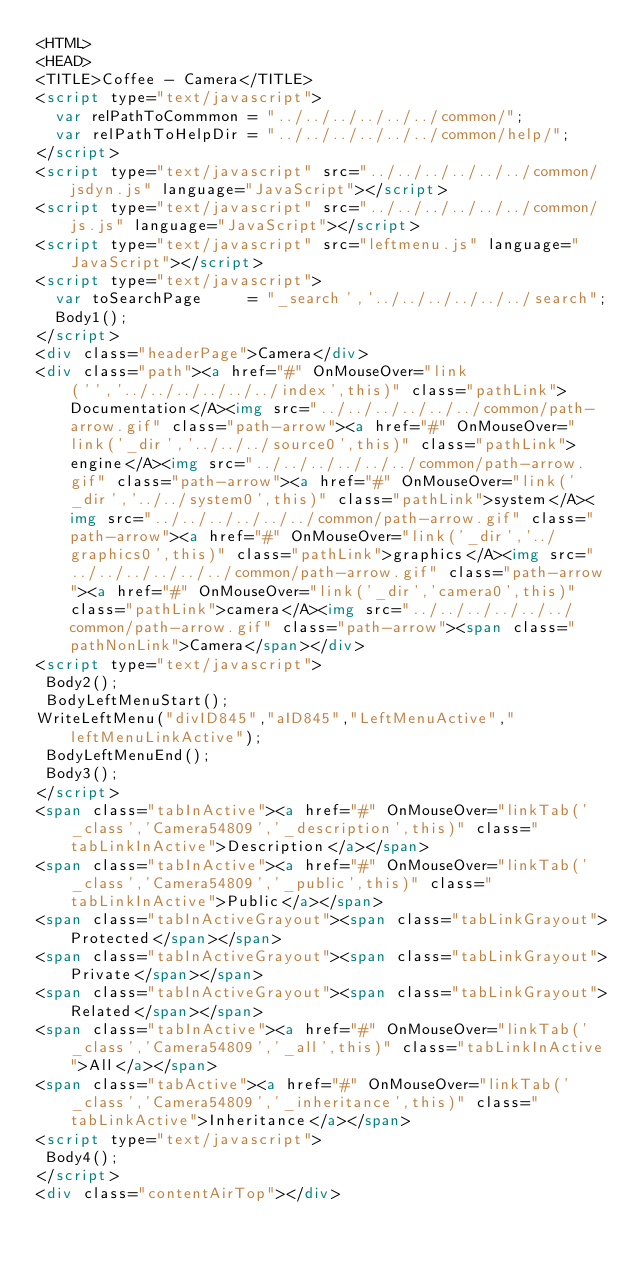<code> <loc_0><loc_0><loc_500><loc_500><_HTML_><HTML>
<HEAD>
<TITLE>Coffee - Camera</TITLE>
<script type="text/javascript">
  var relPathToCommmon = "../../../../../../common/";
  var relPathToHelpDir = "../../../../../../common/help/";
</script>
<script type="text/javascript" src="../../../../../../common/jsdyn.js" language="JavaScript"></script>
<script type="text/javascript" src="../../../../../../common/js.js" language="JavaScript"></script>
<script type="text/javascript" src="leftmenu.js" language="JavaScript"></script>
<script type="text/javascript">
  var toSearchPage     = "_search','../../../../../../search";
  Body1();
</script>
<div class="headerPage">Camera</div>
<div class="path"><a href="#" OnMouseOver="link('','../../../../../../index',this)" class="pathLink">Documentation</A><img src="../../../../../../common/path-arrow.gif" class="path-arrow"><a href="#" OnMouseOver="link('_dir','../../../source0',this)" class="pathLink">engine</A><img src="../../../../../../common/path-arrow.gif" class="path-arrow"><a href="#" OnMouseOver="link('_dir','../../system0',this)" class="pathLink">system</A><img src="../../../../../../common/path-arrow.gif" class="path-arrow"><a href="#" OnMouseOver="link('_dir','../graphics0',this)" class="pathLink">graphics</A><img src="../../../../../../common/path-arrow.gif" class="path-arrow"><a href="#" OnMouseOver="link('_dir','camera0',this)" class="pathLink">camera</A><img src="../../../../../../common/path-arrow.gif" class="path-arrow"><span class="pathNonLink">Camera</span></div>
<script type="text/javascript">
 Body2();
 BodyLeftMenuStart();
WriteLeftMenu("divID845","aID845","LeftMenuActive","leftMenuLinkActive");
 BodyLeftMenuEnd();
 Body3();
</script>
<span class="tabInActive"><a href="#" OnMouseOver="linkTab('_class','Camera54809','_description',this)" class="tabLinkInActive">Description</a></span>
<span class="tabInActive"><a href="#" OnMouseOver="linkTab('_class','Camera54809','_public',this)" class="tabLinkInActive">Public</a></span>
<span class="tabInActiveGrayout"><span class="tabLinkGrayout">Protected</span></span>
<span class="tabInActiveGrayout"><span class="tabLinkGrayout">Private</span></span>
<span class="tabInActiveGrayout"><span class="tabLinkGrayout">Related</span></span>
<span class="tabInActive"><a href="#" OnMouseOver="linkTab('_class','Camera54809','_all',this)" class="tabLinkInActive">All</a></span>
<span class="tabActive"><a href="#" OnMouseOver="linkTab('_class','Camera54809','_inheritance',this)" class="tabLinkActive">Inheritance</a></span>
<script type="text/javascript">
 Body4();
</script>
<div class="contentAirTop"></div></code> 